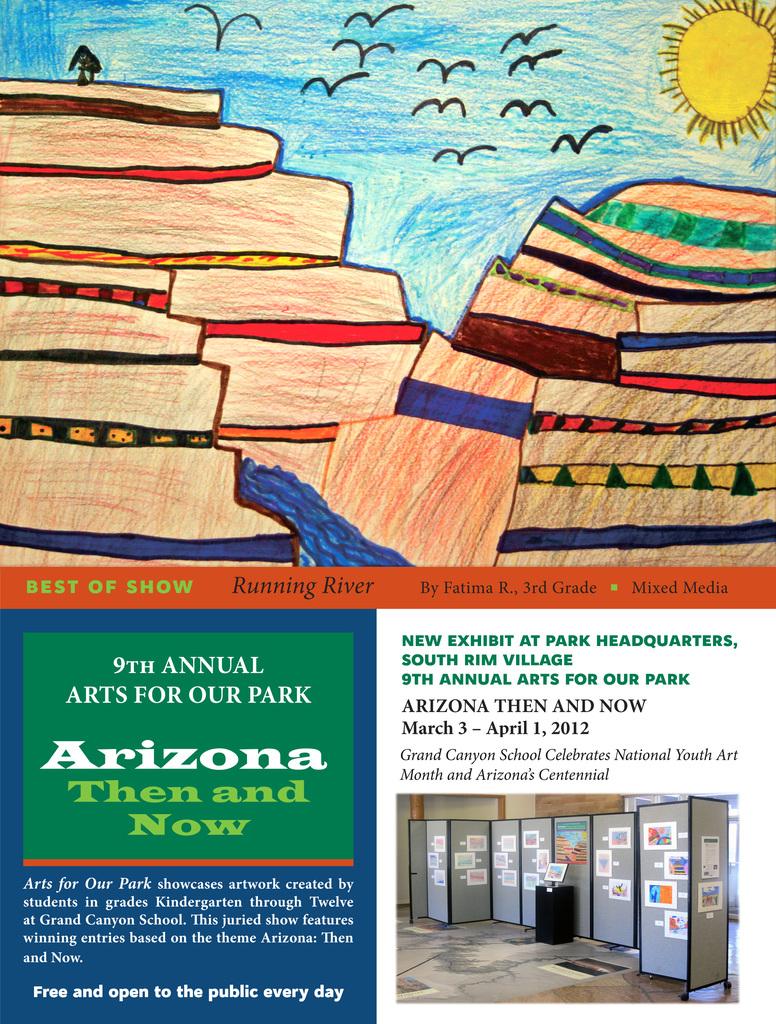What is the dates on the picture?
Ensure brevity in your answer.  March 3 - april 1, 2012. What state name is on the bottom left picture?
Provide a short and direct response. Arizona. 